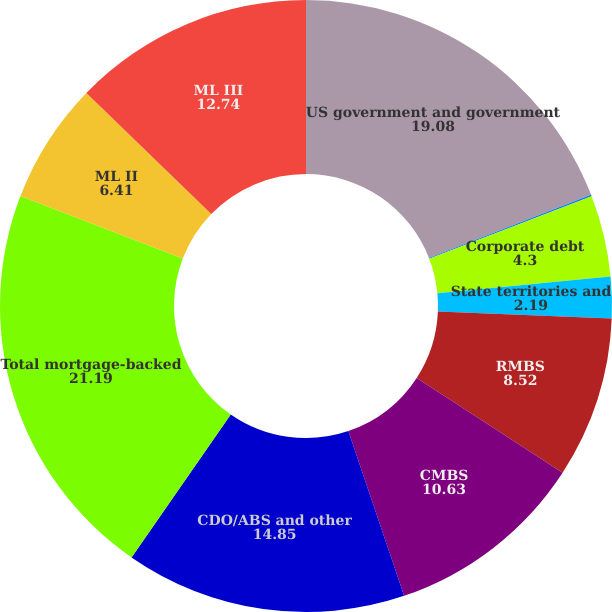Convert chart. <chart><loc_0><loc_0><loc_500><loc_500><pie_chart><fcel>US government and government<fcel>Non-US governments<fcel>Corporate debt<fcel>State territories and<fcel>RMBS<fcel>CMBS<fcel>CDO/ABS and other<fcel>Total mortgage-backed<fcel>ML II<fcel>ML III<nl><fcel>19.08%<fcel>0.08%<fcel>4.3%<fcel>2.19%<fcel>8.52%<fcel>10.63%<fcel>14.85%<fcel>21.19%<fcel>6.41%<fcel>12.74%<nl></chart> 